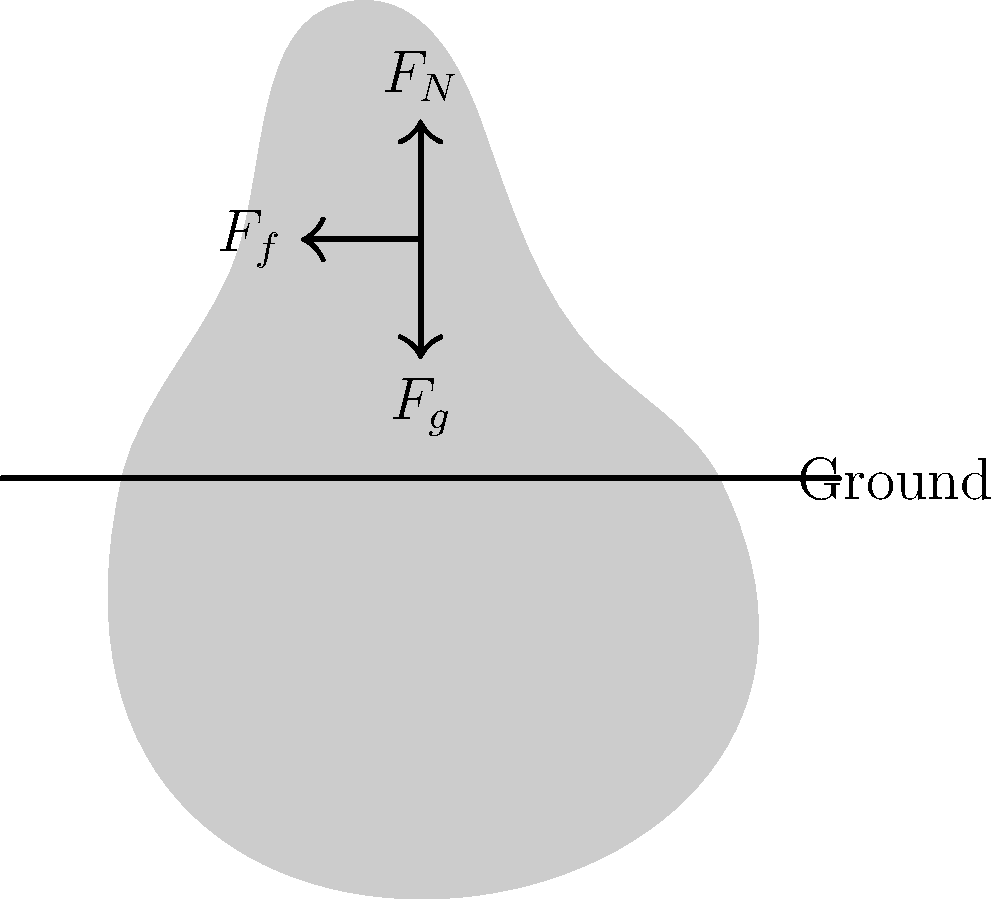In a sliding tackle reminiscent of Diego Costa's aggressive style, what is the primary force that opposes the player's motion along the ground, and how does it relate to the normal force? To understand the forces involved in a sliding tackle, let's break it down step-by-step:

1. Gravity ($F_g$): This force acts downward on the player, pulling them towards the center of the Earth.

2. Normal force ($F_N$): This is the upward force exerted by the ground on the player, counteracting gravity.

3. Friction force ($F_f$): This is the force that opposes the motion of the player along the ground.

The relationship between friction and normal force is given by the equation:

$$F_f = \mu F_N$$

Where $\mu$ is the coefficient of friction between the player's body/clothing and the ground.

In a sliding tackle:
- The friction force is the primary force opposing the player's motion.
- It is directly proportional to the normal force.
- A higher normal force (e.g., more of the player's weight on the ground) will result in a higher friction force.
- The coefficient of friction depends on the surfaces in contact (e.g., grass, player's kit material).

Diego Costa, known for his physical play, would often use sliding tackles effectively by maximizing the normal force (putting more of his weight into the tackle) to increase friction and slow down or stop the opponent more quickly.
Answer: Friction force; directly proportional to normal force 